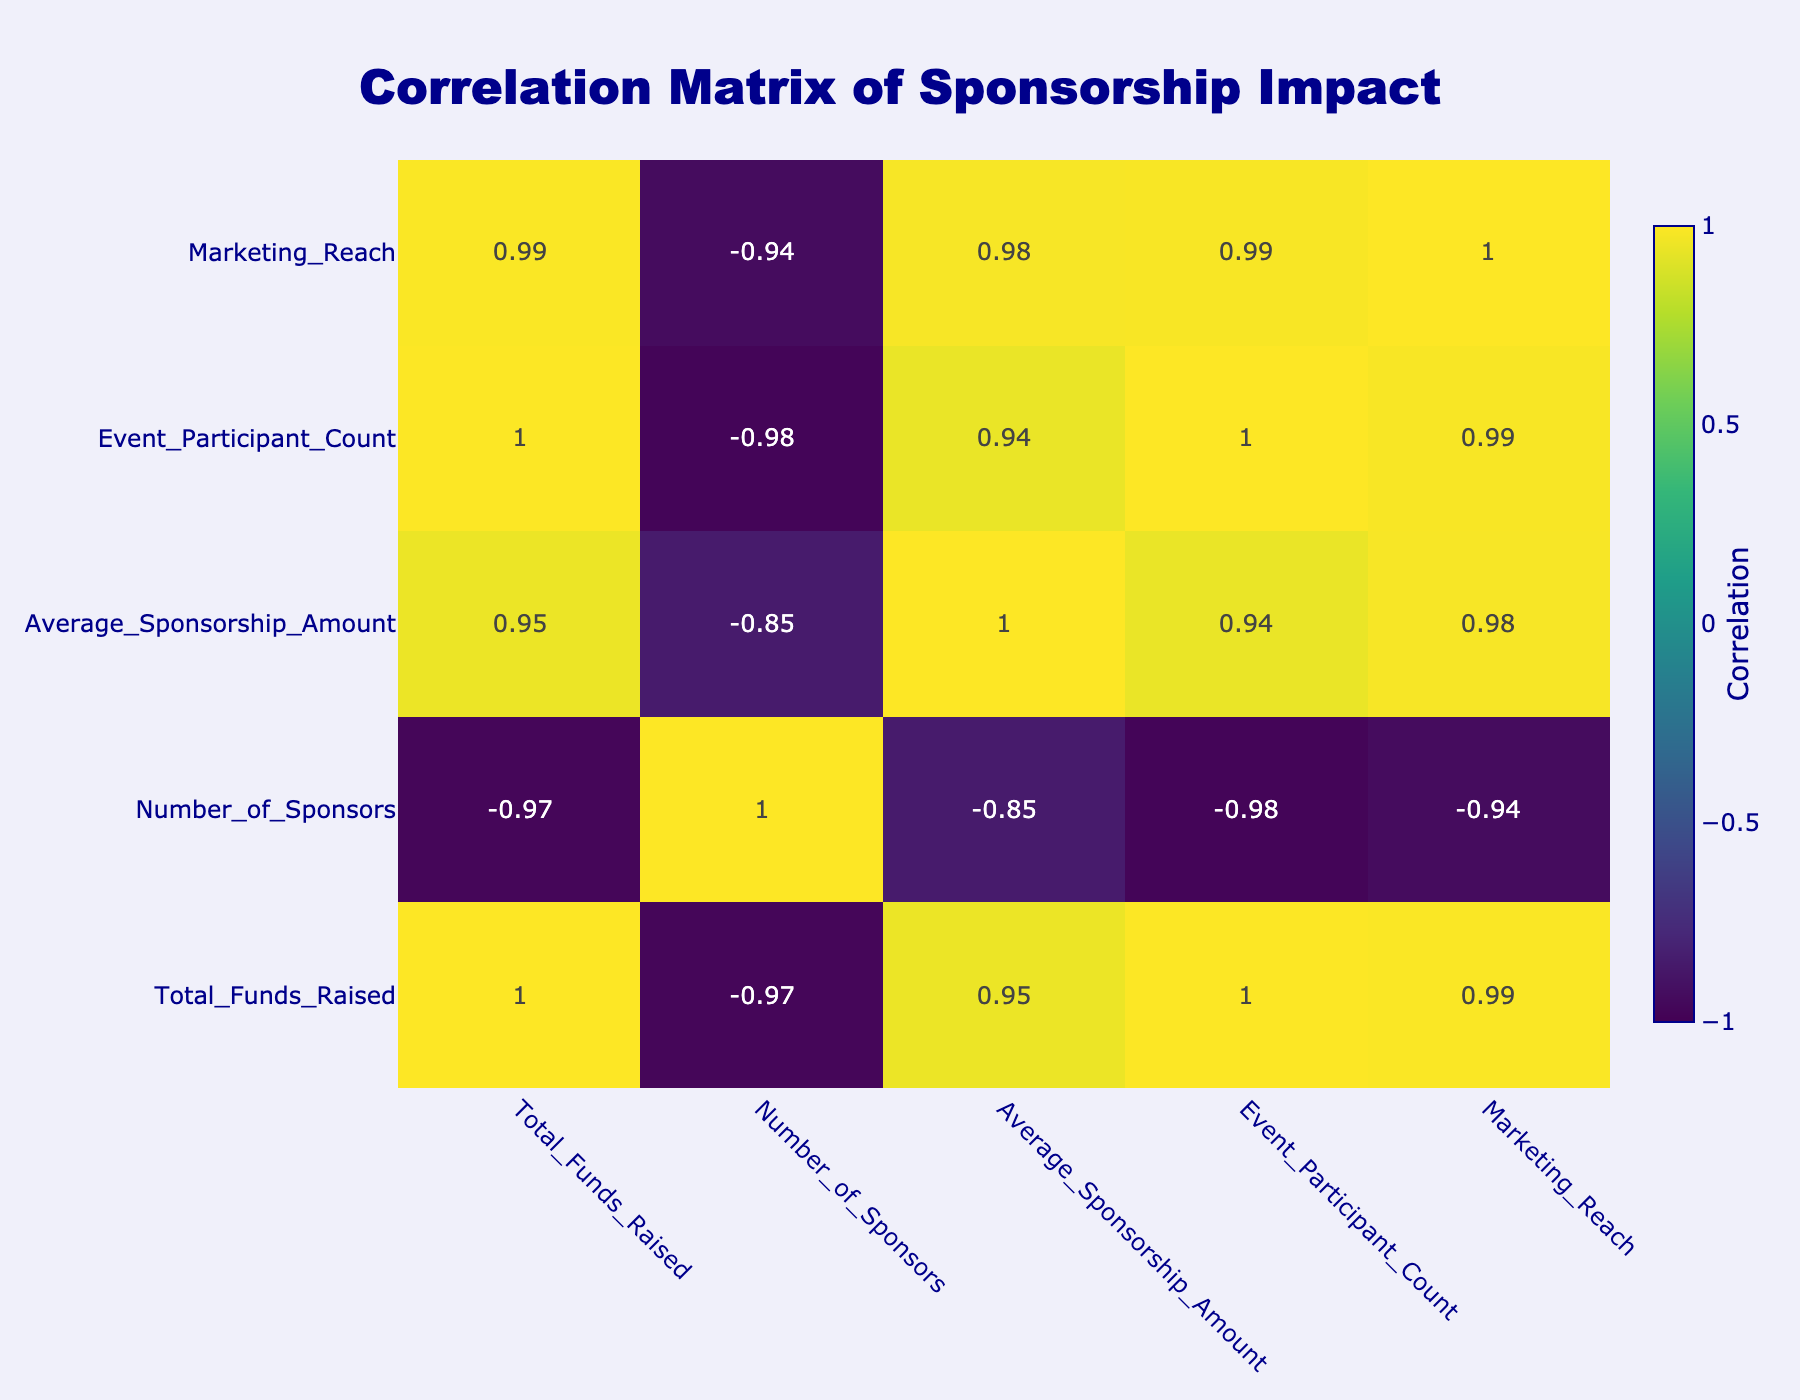What is the highest Total Funds Raised among the sponsorship levels? The highest value in the Total Funds Raised column is 200000, associated with the Platinum sponsorship level.
Answer: 200000 How many sponsors are there for the Gold sponsorship level? The Gold sponsorship level has 5 sponsors, which is directly indicated in the Number_of_Sponsors column.
Answer: 5 What is the Average Sponsorship Amount for the Bronze level? The Average Sponsorship Amount for the Bronze level is 4000, as seen in that specific row of the table.
Answer: 4000 Is there a higher Average Sponsorship Amount for Gold or Silver? The Average Sponsorship Amount for Gold is 30000 while Silver is 10000. Since 30000 is greater than 10000, Gold has a higher average.
Answer: Yes What is the total number of sponsors across all levels? To find the total number of sponsors, we sum the Number_of_Sponsors for each level: 5 + 10 + 15 + 3 + 20 = 53.
Answer: 53 If we have a total participant count of 10000 across all sponsorship levels, what percentage is made up by the Gold level participants? The Gold level has 2000 participants. The percentage is calculated as (2000 / 10000) * 100 = 20%.
Answer: 20% Does the Community sponsorship level contribute more to Total Funds Raised than the Bronze level? The Total Funds Raised for Community is 35000 and for Bronze is 60000. Since 35000 is less than 60000, it does not contribute more.
Answer: No What is the difference in Total Funds Raised between Platinum and Gold levels? The Total Funds Raised for Platinum is 200000 and for Gold is 150000. The difference is 200000 - 150000 = 50000.
Answer: 50000 Which sponsorship level has the least Marketing Reach? The Community sponsorship level has the least Marketing Reach at 8000, as shown in the Marketing_Reach column.
Answer: Community 